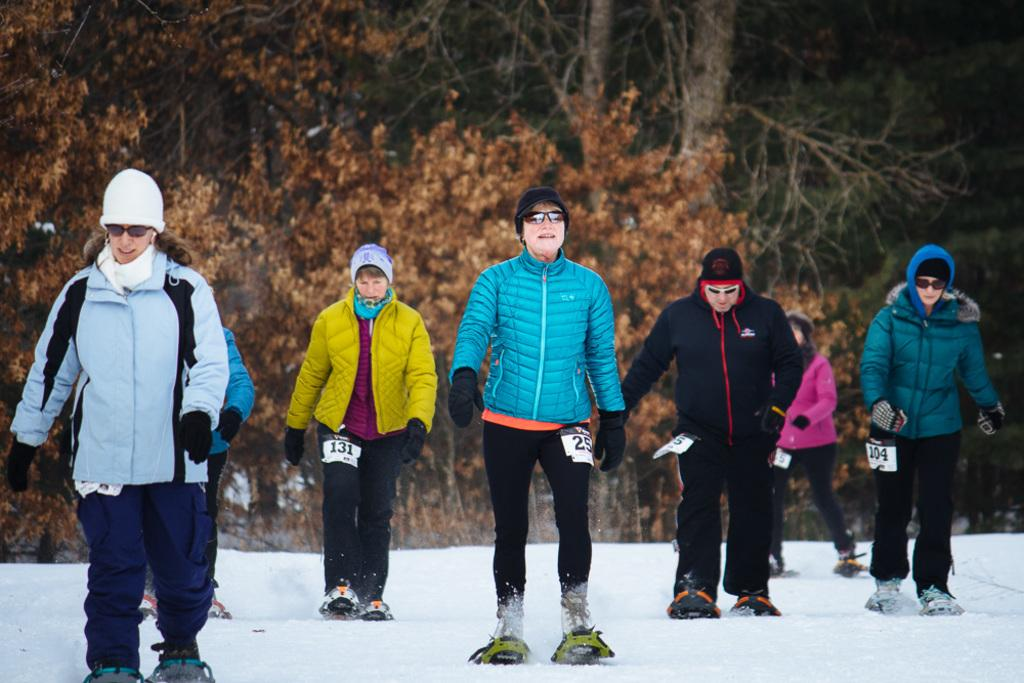What is the main subject of the image? The main subject of the image is a group of people. What are the people doing in the image? The people are standing in the snow and wearing skis. What can be seen in the background of the image? There is a group of trees visible in the background of the image. How many ants are visible on the skis in the image? There are no ants present in the image, and therefore none can be seen on the skis. 